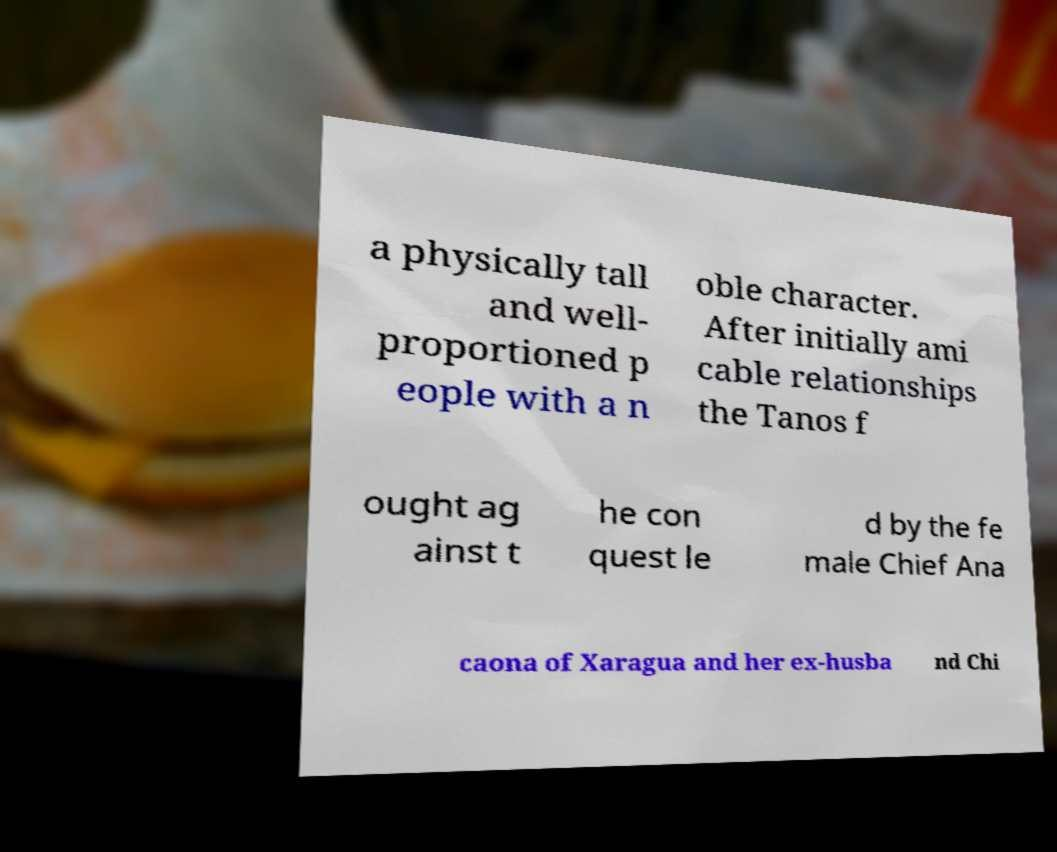Can you accurately transcribe the text from the provided image for me? a physically tall and well- proportioned p eople with a n oble character. After initially ami cable relationships the Tanos f ought ag ainst t he con quest le d by the fe male Chief Ana caona of Xaragua and her ex-husba nd Chi 